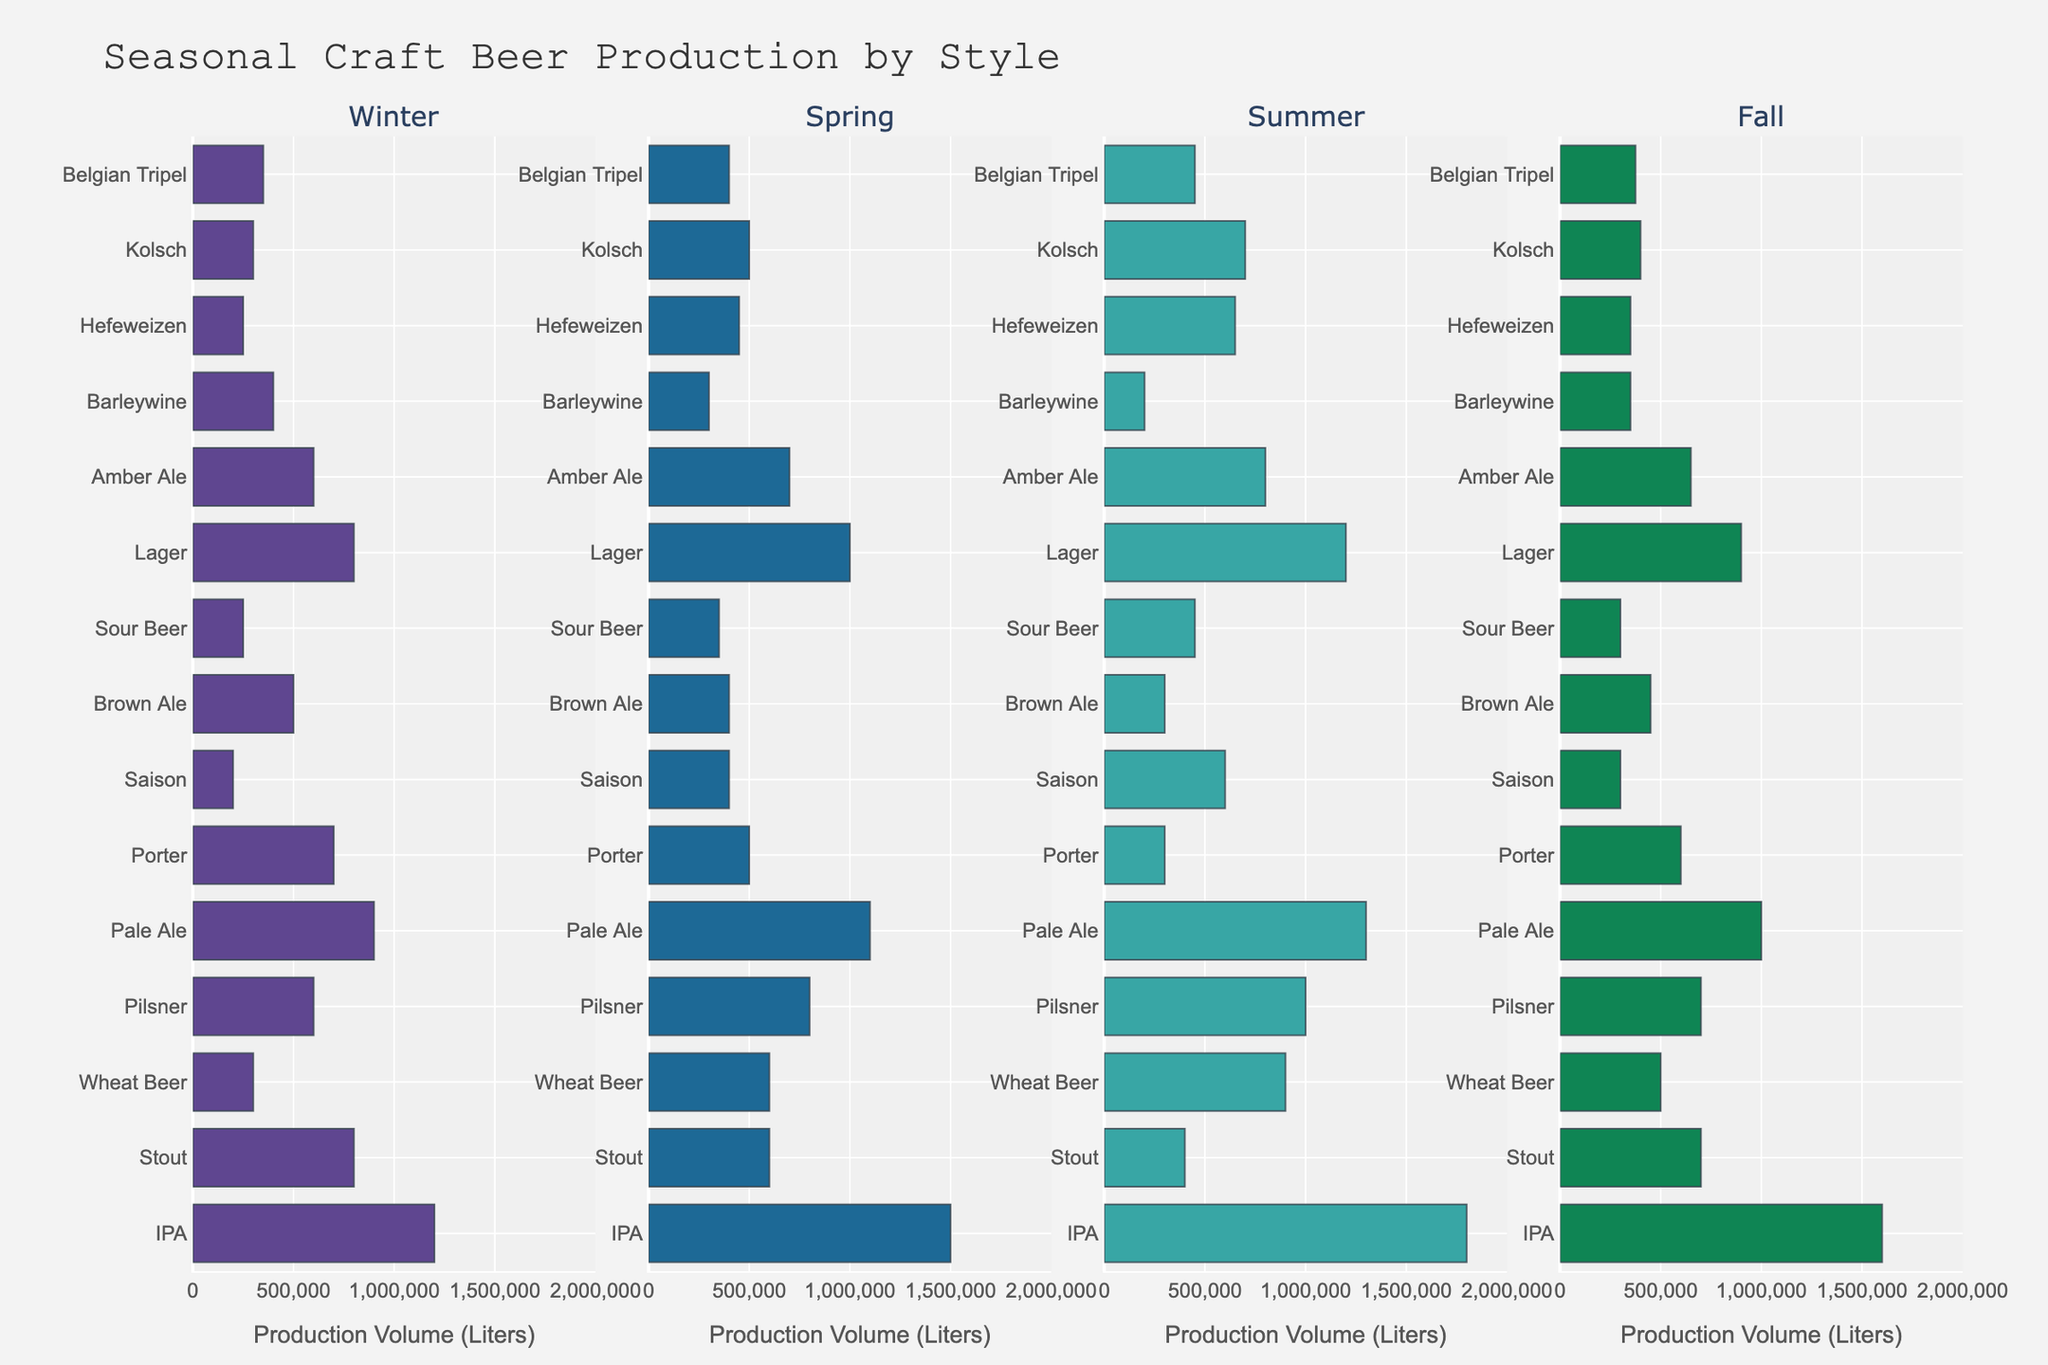which craft beer style has the highest production volume in the summer? To find the style with the highest production volume in the summer, look at the summer column and identify the largest value. IPA has the highest summer production volume with 1,800,000 liters.
Answer: IPA how does the production volume of stout differ between winter and spring? To determine the difference in stout production between winter and spring, subtract the spring volume from the winter volume (800,000 - 600,000). The difference is 200,000 liters.
Answer: 200,000 liters which season sees the highest overall production for pale ale? To find the season with the highest pale ale production, compare the values across all seasons for pale ale. The summer season has the highest production at 1,300,000 liters.
Answer: Summer what is the total production volume for pilsner across all seasons? To calculate the total pilsner production volume, sum the values for all four seasons (600,000 + 800,000 + 1,000,000 + 700,000). The total production volume is 3,100,000 liters.
Answer: 3,100,000 liters compare the production volumes of kolsch and hefeweizen in fall. which one is higher? To compare the fall production volumes of kolsch and hefeweizen, look at their respective values in the fall column. Kolsch has 400,000 liters while hefeweizen has 350,000 liters. Kolsch’s production volume is higher.
Answer: Kolsch what percentage of the total annual IPA production occurs in winter? To find the percentage of the total annual IPA production in winter, divide the winter volume by the total IPA production and multiply by 100 ((1,200,000 / (1,200,000 + 1,500,000 + 1,800,000 + 1,600,000)) * 100). The percentage is approximately 19.35%.
Answer: 19.35% is the spring production volume of Belgian tripel more or less than half its summer production volume? To compare, calculate half of the summer production volume of Belgian tripel (450,000 / 2 = 225,000) and compare it to the spring production volume (400,000). The spring production volume is greater than half of its summer production volume.
Answer: More rank the beers by their summer production from highest to lowest. To rank the beers by summer production, list the styles and their summer volumes in descending order: IPA (1,800,000), Pale Ale (1,300,000), Lager (1,200,000), Pilsner (1,000,000), Wheat Beer (900,000), Amber Ale (800,000), Stout (400,000), Belgian Tripel (450,000), Sour Beer (450,000), Hefeweizen (650,000), Porter (300,000), Kolsch (700,000), Saison (600,000), Porter (300,000), Brown Ale (300,000), Barleywine (200,000).
Answer: IPA, Pale Ale, Lager, Pilsner, Wheat Beer, Amber Ale, Hefeweizen, Kolsch, Saison, Sour Beer, Porter, Brown Ale, Stout, Belgian Tripel, Barleywine does brown ale have higher production in winter or fall? To answer this, compare the winter and fall production volumes of brown ale. Winter has 500,000 liters, while fall has 450,000 liters. Winter production is higher.
Answer: Winter 